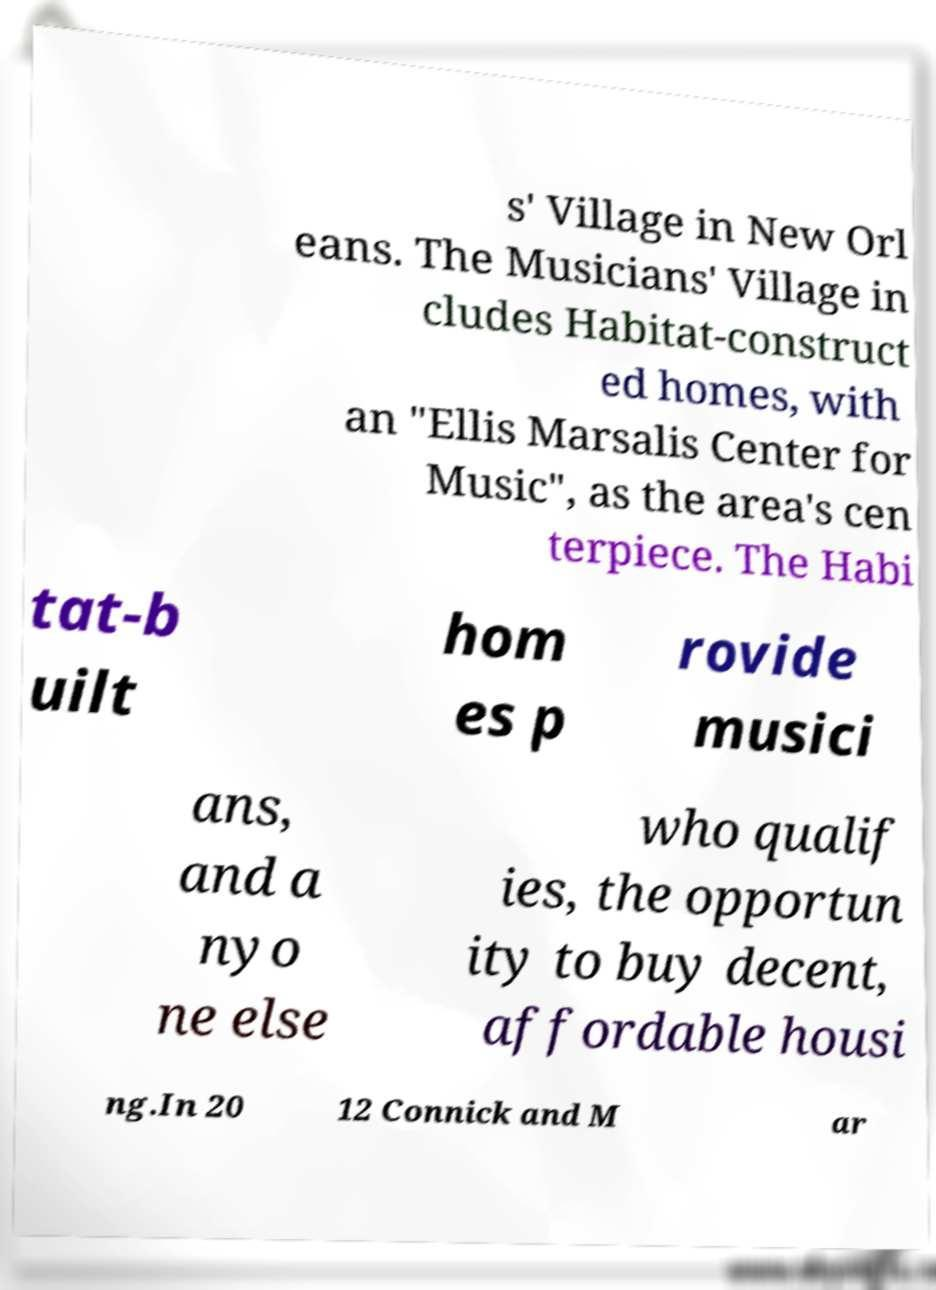Please identify and transcribe the text found in this image. s' Village in New Orl eans. The Musicians' Village in cludes Habitat-construct ed homes, with an "Ellis Marsalis Center for Music", as the area's cen terpiece. The Habi tat-b uilt hom es p rovide musici ans, and a nyo ne else who qualif ies, the opportun ity to buy decent, affordable housi ng.In 20 12 Connick and M ar 